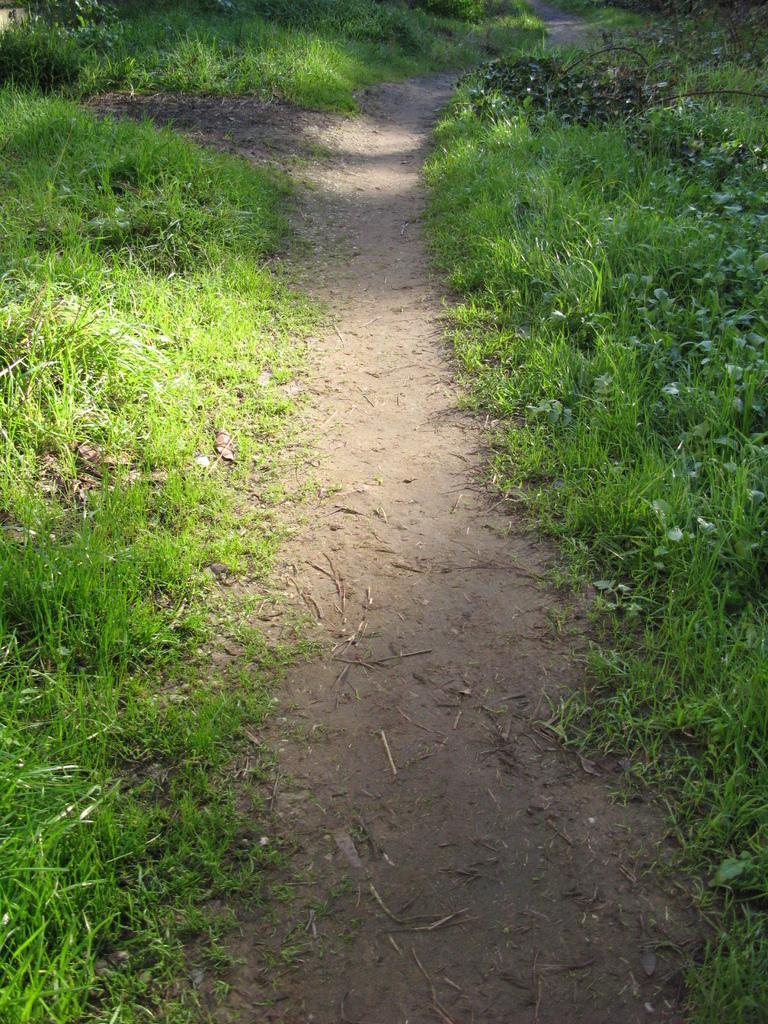In one or two sentences, can you explain what this image depicts? In this image we can see the grass. On the right side of the image we can see few plants. 